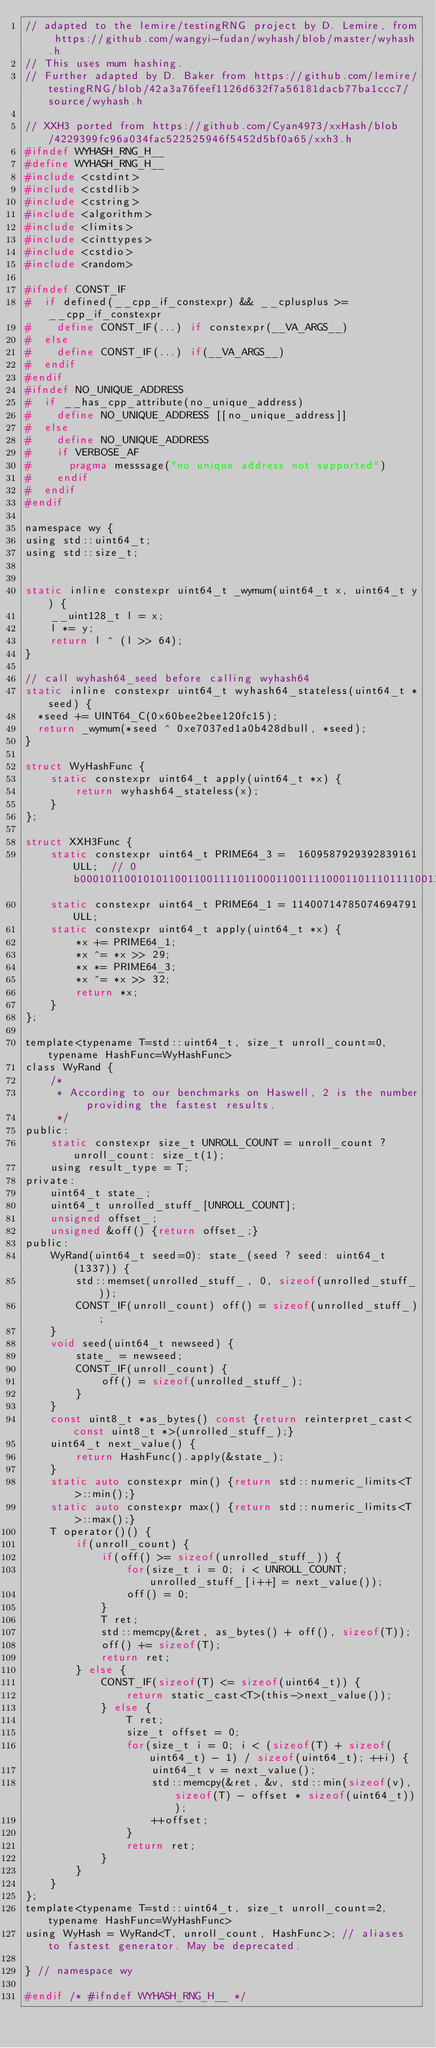Convert code to text. <code><loc_0><loc_0><loc_500><loc_500><_C_>// adapted to the lemire/testingRNG project by D. Lemire, from https://github.com/wangyi-fudan/wyhash/blob/master/wyhash.h
// This uses mum hashing.
// Further adapted by D. Baker from https://github.com/lemire/testingRNG/blob/42a3a76feef1126d632f7a56181dacb77ba1ccc7/source/wyhash.h

// XXH3 ported from https://github.com/Cyan4973/xxHash/blob/4229399fc96a034fac522525946f5452d5bf0a65/xxh3.h
#ifndef WYHASH_RNG_H__
#define WYHASH_RNG_H__
#include <cstdint>
#include <cstdlib>
#include <cstring>
#include <algorithm>
#include <limits>
#include <cinttypes>
#include <cstdio>
#include <random>

#ifndef CONST_IF
#  if defined(__cpp_if_constexpr) && __cplusplus >= __cpp_if_constexpr
#    define CONST_IF(...) if constexpr(__VA_ARGS__)
#  else
#    define CONST_IF(...) if(__VA_ARGS__)
#  endif
#endif
#ifndef NO_UNIQUE_ADDRESS
#  if __has_cpp_attribute(no_unique_address)
#    define NO_UNIQUE_ADDRESS [[no_unique_address]]
#  else
#    define NO_UNIQUE_ADDRESS
#    if VERBOSE_AF
#      pragma messsage("no unique address not supported")
#    endif
#  endif
#endif

namespace wy {
using std::uint64_t;
using std::size_t;


static inline constexpr uint64_t _wymum(uint64_t x, uint64_t y) {
    __uint128_t l = x;
    l *= y;
    return l ^ (l >> 64);
}

// call wyhash64_seed before calling wyhash64
static inline constexpr uint64_t wyhash64_stateless(uint64_t *seed) {
  *seed += UINT64_C(0x60bee2bee120fc15);
  return _wymum(*seed ^ 0xe7037ed1a0b428dbull, *seed);
}

struct WyHashFunc {
    static constexpr uint64_t apply(uint64_t *x) {
        return wyhash64_stateless(x);
    }
};

struct XXH3Func {
    static constexpr uint64_t PRIME64_3 =  1609587929392839161ULL;  // 0b0001011001010110011001111011000110011110001101110111100111111001
    static constexpr uint64_t PRIME64_1 = 11400714785074694791ULL;
    static constexpr uint64_t apply(uint64_t *x) {
        *x += PRIME64_1;
        *x ^= *x >> 29;
        *x *= PRIME64_3;
        *x ^= *x >> 32;
        return *x;
    }
};

template<typename T=std::uint64_t, size_t unroll_count=0, typename HashFunc=WyHashFunc>
class WyRand {
    /*
     * According to our benchmarks on Haswell, 2 is the number providing the fastest results.
     */
public:
    static constexpr size_t UNROLL_COUNT = unroll_count ? unroll_count: size_t(1);
    using result_type = T;
private:
    uint64_t state_;
    uint64_t unrolled_stuff_[UNROLL_COUNT];
    unsigned offset_;
    unsigned &off() {return offset_;}
public:
    WyRand(uint64_t seed=0): state_(seed ? seed: uint64_t(1337)) {
        std::memset(unrolled_stuff_, 0, sizeof(unrolled_stuff_));
        CONST_IF(unroll_count) off() = sizeof(unrolled_stuff_);
    }
    void seed(uint64_t newseed) {
        state_ = newseed;
        CONST_IF(unroll_count) {
            off() = sizeof(unrolled_stuff_);
        }
    }
    const uint8_t *as_bytes() const {return reinterpret_cast<const uint8_t *>(unrolled_stuff_);}
    uint64_t next_value() {
        return HashFunc().apply(&state_);
    }
    static auto constexpr min() {return std::numeric_limits<T>::min();}
    static auto constexpr max() {return std::numeric_limits<T>::max();}
    T operator()() {
        if(unroll_count) {
            if(off() >= sizeof(unrolled_stuff_)) {
                for(size_t i = 0; i < UNROLL_COUNT; unrolled_stuff_[i++] = next_value());
                off() = 0;
            }
            T ret;
            std::memcpy(&ret, as_bytes() + off(), sizeof(T));
            off() += sizeof(T);
            return ret;
        } else {
            CONST_IF(sizeof(T) <= sizeof(uint64_t)) {
                return static_cast<T>(this->next_value());
            } else {
                T ret;
                size_t offset = 0;
                for(size_t i = 0; i < (sizeof(T) + sizeof(uint64_t) - 1) / sizeof(uint64_t); ++i) {
                    uint64_t v = next_value();
                    std::memcpy(&ret, &v, std::min(sizeof(v), sizeof(T) - offset * sizeof(uint64_t)));
                    ++offset;
                }
                return ret;
            }
        }
    }
};
template<typename T=std::uint64_t, size_t unroll_count=2, typename HashFunc=WyHashFunc>
using WyHash = WyRand<T, unroll_count, HashFunc>; // aliases to fastest generator. May be deprecated.

} // namespace wy

#endif /* #ifndef WYHASH_RNG_H__ */
</code> 